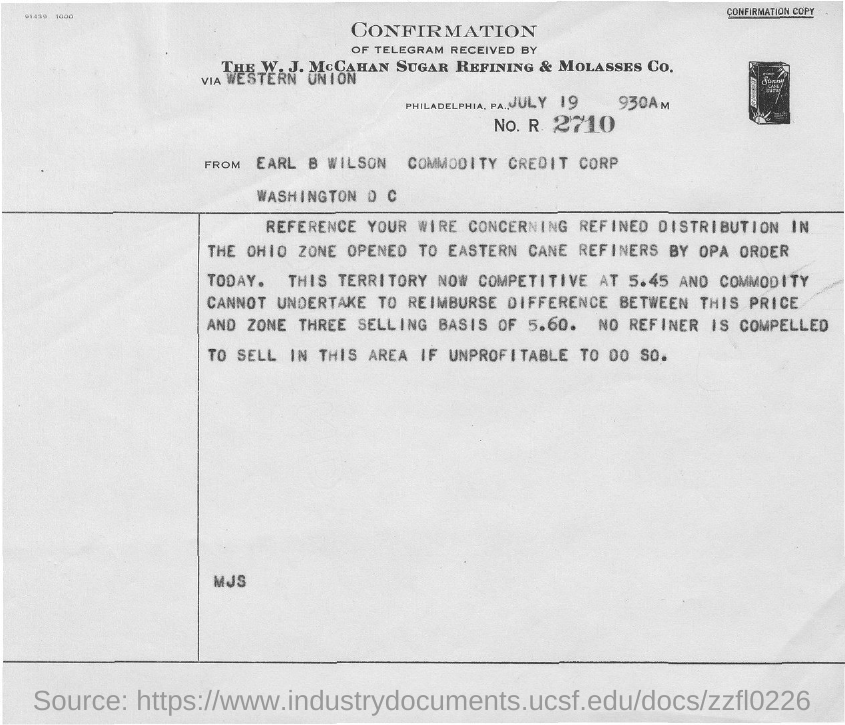Give some essential details in this illustration. The date is July 19... 